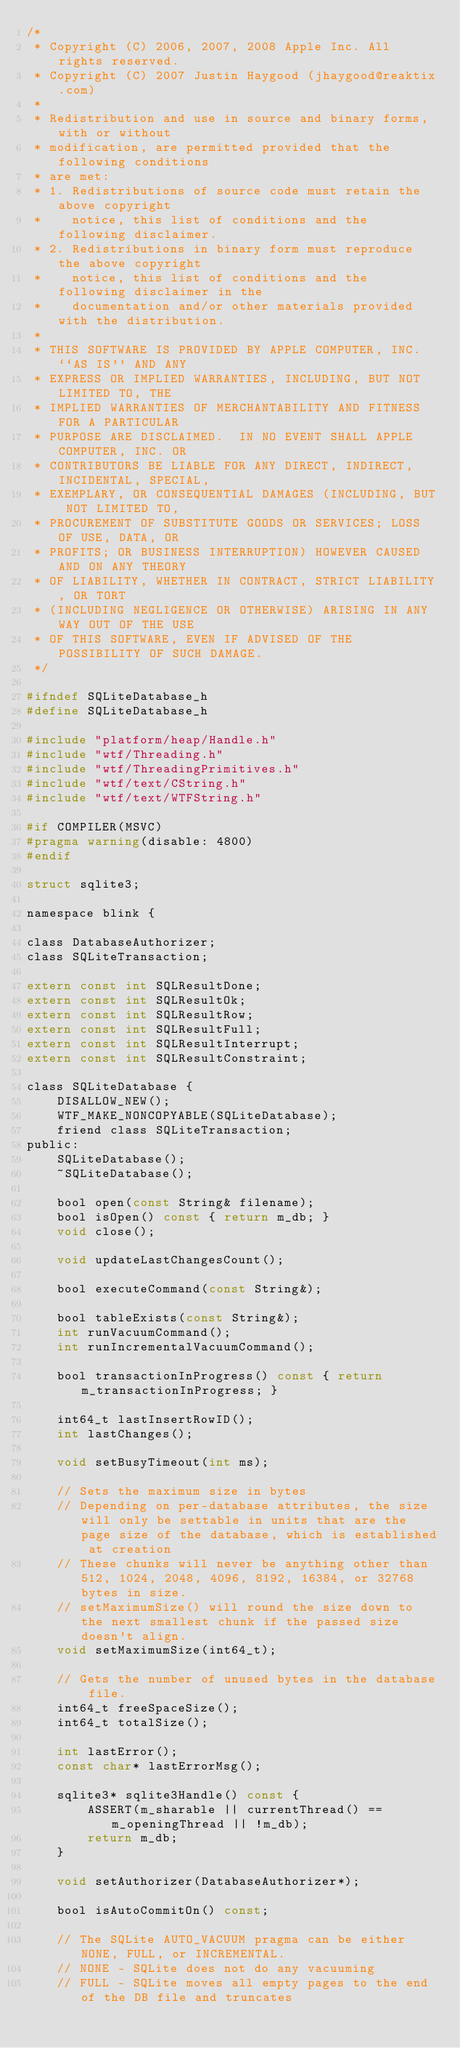Convert code to text. <code><loc_0><loc_0><loc_500><loc_500><_C_>/*
 * Copyright (C) 2006, 2007, 2008 Apple Inc. All rights reserved.
 * Copyright (C) 2007 Justin Haygood (jhaygood@reaktix.com)
 *
 * Redistribution and use in source and binary forms, with or without
 * modification, are permitted provided that the following conditions
 * are met:
 * 1. Redistributions of source code must retain the above copyright
 *    notice, this list of conditions and the following disclaimer.
 * 2. Redistributions in binary form must reproduce the above copyright
 *    notice, this list of conditions and the following disclaimer in the
 *    documentation and/or other materials provided with the distribution.
 *
 * THIS SOFTWARE IS PROVIDED BY APPLE COMPUTER, INC. ``AS IS'' AND ANY
 * EXPRESS OR IMPLIED WARRANTIES, INCLUDING, BUT NOT LIMITED TO, THE
 * IMPLIED WARRANTIES OF MERCHANTABILITY AND FITNESS FOR A PARTICULAR
 * PURPOSE ARE DISCLAIMED.  IN NO EVENT SHALL APPLE COMPUTER, INC. OR
 * CONTRIBUTORS BE LIABLE FOR ANY DIRECT, INDIRECT, INCIDENTAL, SPECIAL,
 * EXEMPLARY, OR CONSEQUENTIAL DAMAGES (INCLUDING, BUT NOT LIMITED TO,
 * PROCUREMENT OF SUBSTITUTE GOODS OR SERVICES; LOSS OF USE, DATA, OR
 * PROFITS; OR BUSINESS INTERRUPTION) HOWEVER CAUSED AND ON ANY THEORY
 * OF LIABILITY, WHETHER IN CONTRACT, STRICT LIABILITY, OR TORT
 * (INCLUDING NEGLIGENCE OR OTHERWISE) ARISING IN ANY WAY OUT OF THE USE
 * OF THIS SOFTWARE, EVEN IF ADVISED OF THE POSSIBILITY OF SUCH DAMAGE.
 */

#ifndef SQLiteDatabase_h
#define SQLiteDatabase_h

#include "platform/heap/Handle.h"
#include "wtf/Threading.h"
#include "wtf/ThreadingPrimitives.h"
#include "wtf/text/CString.h"
#include "wtf/text/WTFString.h"

#if COMPILER(MSVC)
#pragma warning(disable: 4800)
#endif

struct sqlite3;

namespace blink {

class DatabaseAuthorizer;
class SQLiteTransaction;

extern const int SQLResultDone;
extern const int SQLResultOk;
extern const int SQLResultRow;
extern const int SQLResultFull;
extern const int SQLResultInterrupt;
extern const int SQLResultConstraint;

class SQLiteDatabase {
    DISALLOW_NEW();
    WTF_MAKE_NONCOPYABLE(SQLiteDatabase);
    friend class SQLiteTransaction;
public:
    SQLiteDatabase();
    ~SQLiteDatabase();

    bool open(const String& filename);
    bool isOpen() const { return m_db; }
    void close();

    void updateLastChangesCount();

    bool executeCommand(const String&);

    bool tableExists(const String&);
    int runVacuumCommand();
    int runIncrementalVacuumCommand();

    bool transactionInProgress() const { return m_transactionInProgress; }

    int64_t lastInsertRowID();
    int lastChanges();

    void setBusyTimeout(int ms);

    // Sets the maximum size in bytes
    // Depending on per-database attributes, the size will only be settable in units that are the page size of the database, which is established at creation
    // These chunks will never be anything other than 512, 1024, 2048, 4096, 8192, 16384, or 32768 bytes in size.
    // setMaximumSize() will round the size down to the next smallest chunk if the passed size doesn't align.
    void setMaximumSize(int64_t);

    // Gets the number of unused bytes in the database file.
    int64_t freeSpaceSize();
    int64_t totalSize();

    int lastError();
    const char* lastErrorMsg();

    sqlite3* sqlite3Handle() const {
        ASSERT(m_sharable || currentThread() == m_openingThread || !m_db);
        return m_db;
    }

    void setAuthorizer(DatabaseAuthorizer*);

    bool isAutoCommitOn() const;

    // The SQLite AUTO_VACUUM pragma can be either NONE, FULL, or INCREMENTAL.
    // NONE - SQLite does not do any vacuuming
    // FULL - SQLite moves all empty pages to the end of the DB file and truncates</code> 